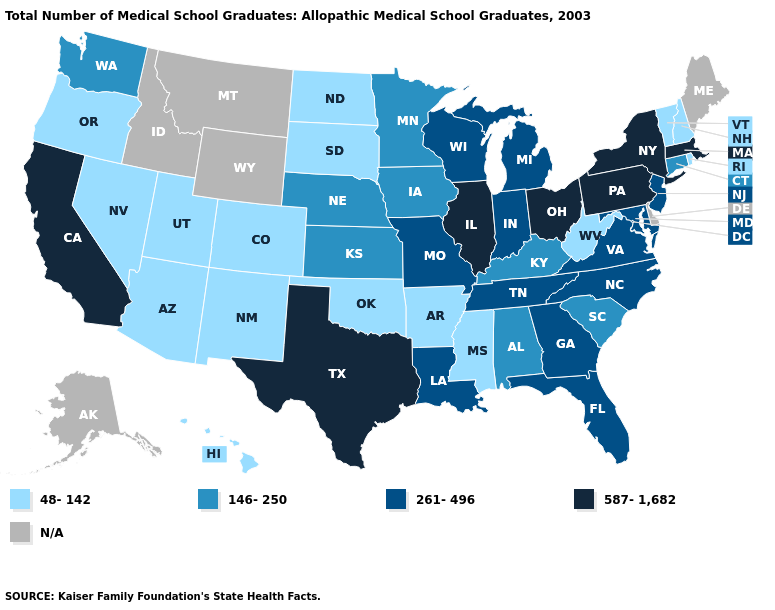Name the states that have a value in the range 261-496?
Concise answer only. Florida, Georgia, Indiana, Louisiana, Maryland, Michigan, Missouri, New Jersey, North Carolina, Tennessee, Virginia, Wisconsin. Among the states that border Maine , which have the lowest value?
Short answer required. New Hampshire. What is the value of Michigan?
Keep it brief. 261-496. Does Mississippi have the lowest value in the South?
Quick response, please. Yes. What is the value of Hawaii?
Give a very brief answer. 48-142. Which states hav the highest value in the South?
Keep it brief. Texas. Name the states that have a value in the range N/A?
Answer briefly. Alaska, Delaware, Idaho, Maine, Montana, Wyoming. Does New Jersey have the highest value in the Northeast?
Give a very brief answer. No. What is the value of Illinois?
Concise answer only. 587-1,682. Which states have the highest value in the USA?
Short answer required. California, Illinois, Massachusetts, New York, Ohio, Pennsylvania, Texas. Does New Mexico have the highest value in the USA?
Give a very brief answer. No. Name the states that have a value in the range 48-142?
Concise answer only. Arizona, Arkansas, Colorado, Hawaii, Mississippi, Nevada, New Hampshire, New Mexico, North Dakota, Oklahoma, Oregon, Rhode Island, South Dakota, Utah, Vermont, West Virginia. What is the value of Minnesota?
Short answer required. 146-250. 